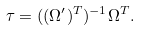<formula> <loc_0><loc_0><loc_500><loc_500>\tau = ( ( \Omega ^ { \prime } ) ^ { T } ) ^ { - 1 } \Omega ^ { T } .</formula> 